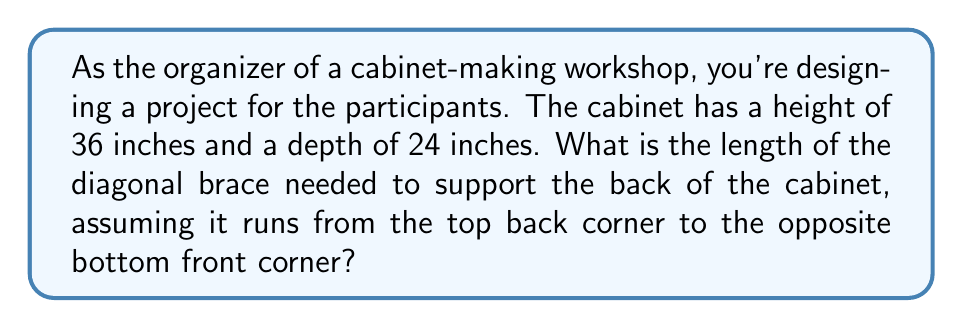Can you solve this math problem? Let's approach this step-by-step:

1) The diagonal brace forms the hypotenuse of a right triangle. The other two sides of this triangle are:
   - The height of the cabinet (36 inches)
   - The diagonal of the cabinet's base

2) To find the diagonal of the base, we need to use the Pythagorean theorem. The base forms a right triangle with:
   - Width (let's assume it's 18 inches, a common cabinet width)
   - Depth (24 inches)

3) Let's call the base diagonal $d$. Using the Pythagorean theorem:

   $$d^2 = 18^2 + 24^2$$
   $$d^2 = 324 + 576 = 900$$
   $$d = \sqrt{900} = 30\text{ inches}$$

4) Now we have a new right triangle with:
   - Height: 36 inches
   - Base: 30 inches (the diagonal we just calculated)

5) Let's call the length of the brace $x$. Using the Pythagorean theorem again:

   $$x^2 = 36^2 + 30^2$$
   $$x^2 = 1296 + 900 = 2196$$
   $$x = \sqrt{2196} \approx 46.86\text{ inches}$$

[asy]
import geometry;

pair A=(0,0), B=(18,0), C=(18,24), D=(0,24), E=(0,36), F=(18,36);
draw(A--B--C--D--cycle);
draw(D--E--F--C);
draw(E--C,dashed);

label("36\"", E--D, W);
label("24\"", D--C, S);
label("18\"", A--B, S);
label("30\"", A--C, SE);
label("46.86\"", E--C, NE);

[/asy]
Answer: The length of the diagonal brace needed is approximately 46.86 inches. 